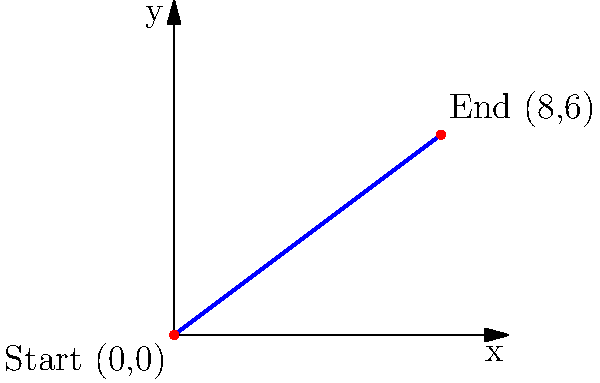During a therapy session, a horse walks in a straight line from the starting point (0,0) to the endpoint (8,6) in a rectangular arena. Find the equation of the line representing the horse's path in slope-intercept form. To find the equation of the line in slope-intercept form $(y = mx + b)$, we need to follow these steps:

1. Calculate the slope $(m)$ of the line:
   $m = \frac{y_2 - y_1}{x_2 - x_1} = \frac{6 - 0}{8 - 0} = \frac{6}{8} = \frac{3}{4}$

2. Use the point-slope form of a line: $y - y_1 = m(x - x_1)$
   We can use either point. Let's use (0,0):
   $y - 0 = \frac{3}{4}(x - 0)$

3. Simplify the equation:
   $y = \frac{3}{4}x$

4. The y-intercept $(b)$ is already 0, so we don't need to add anything.

Therefore, the equation of the line representing the horse's path in slope-intercept form is $y = \frac{3}{4}x$.
Answer: $y = \frac{3}{4}x$ 